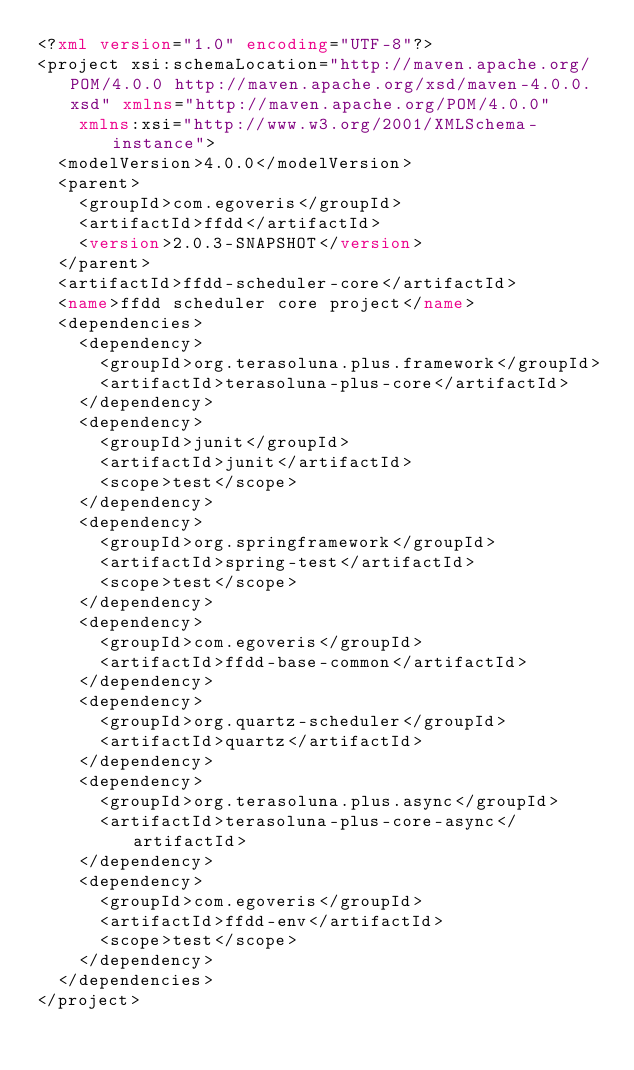<code> <loc_0><loc_0><loc_500><loc_500><_XML_><?xml version="1.0" encoding="UTF-8"?>
<project xsi:schemaLocation="http://maven.apache.org/POM/4.0.0 http://maven.apache.org/xsd/maven-4.0.0.xsd" xmlns="http://maven.apache.org/POM/4.0.0"
    xmlns:xsi="http://www.w3.org/2001/XMLSchema-instance">
  <modelVersion>4.0.0</modelVersion>
  <parent>
    <groupId>com.egoveris</groupId>
    <artifactId>ffdd</artifactId>
    <version>2.0.3-SNAPSHOT</version>
  </parent>
  <artifactId>ffdd-scheduler-core</artifactId>
  <name>ffdd scheduler core project</name>
  <dependencies>
    <dependency>
      <groupId>org.terasoluna.plus.framework</groupId>
      <artifactId>terasoluna-plus-core</artifactId>
    </dependency>
    <dependency>
      <groupId>junit</groupId>
      <artifactId>junit</artifactId>
      <scope>test</scope>
    </dependency>
    <dependency>
      <groupId>org.springframework</groupId>
      <artifactId>spring-test</artifactId>
      <scope>test</scope>
    </dependency>
    <dependency>
      <groupId>com.egoveris</groupId>
      <artifactId>ffdd-base-common</artifactId>
    </dependency>
    <dependency>
      <groupId>org.quartz-scheduler</groupId>
      <artifactId>quartz</artifactId>
    </dependency>
    <dependency>
      <groupId>org.terasoluna.plus.async</groupId>
      <artifactId>terasoluna-plus-core-async</artifactId>
    </dependency>
    <dependency>
      <groupId>com.egoveris</groupId>
      <artifactId>ffdd-env</artifactId>
      <scope>test</scope>
    </dependency>
  </dependencies>
</project></code> 